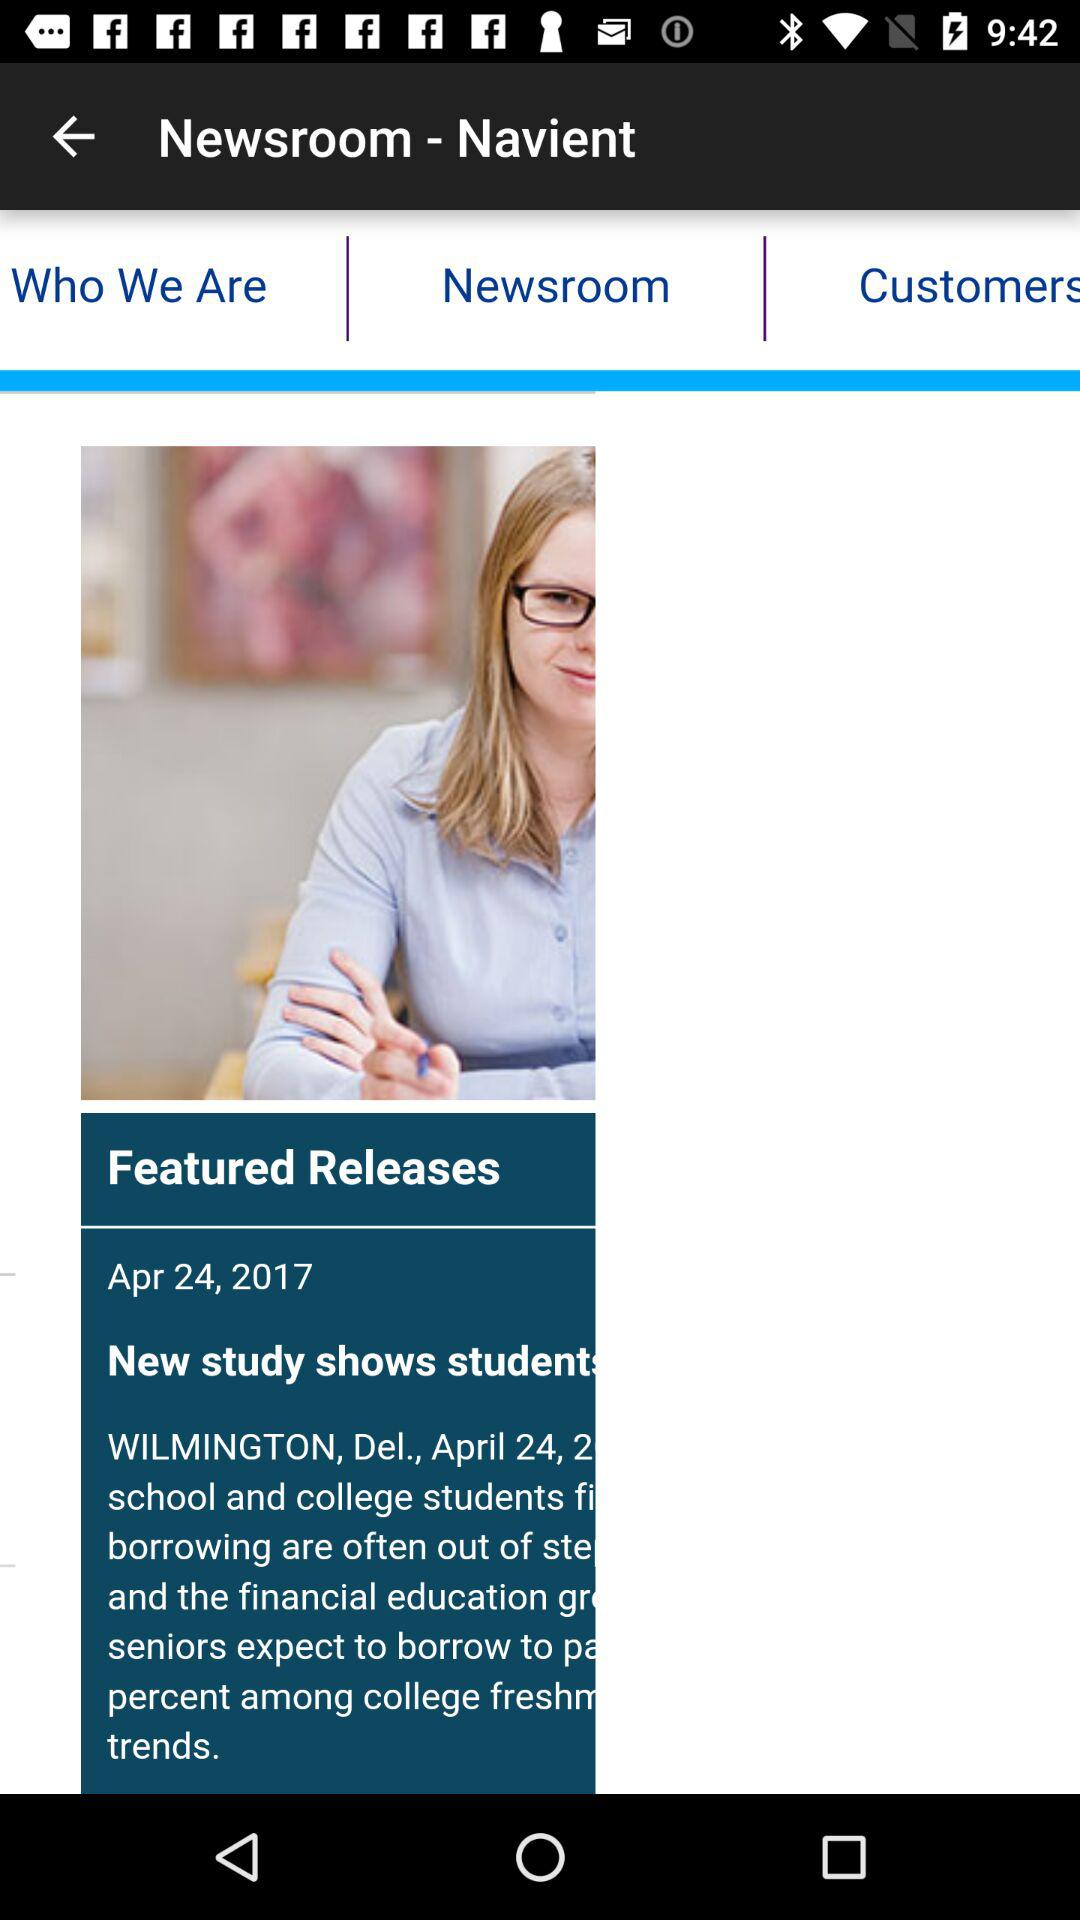Who is "Navient"?
When the provided information is insufficient, respond with <no answer>. <no answer> 